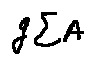<formula> <loc_0><loc_0><loc_500><loc_500>g \sum A</formula> 